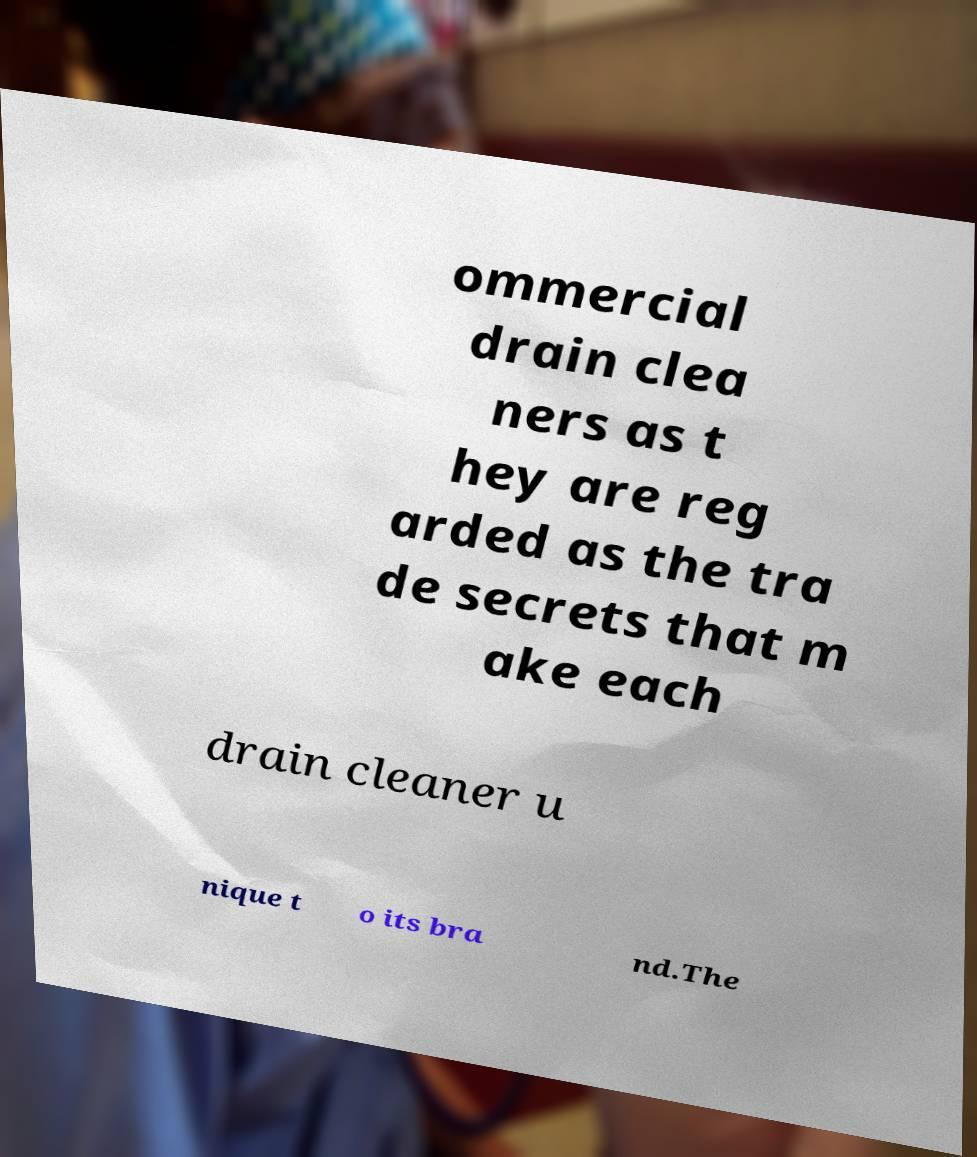Could you assist in decoding the text presented in this image and type it out clearly? ommercial drain clea ners as t hey are reg arded as the tra de secrets that m ake each drain cleaner u nique t o its bra nd.The 